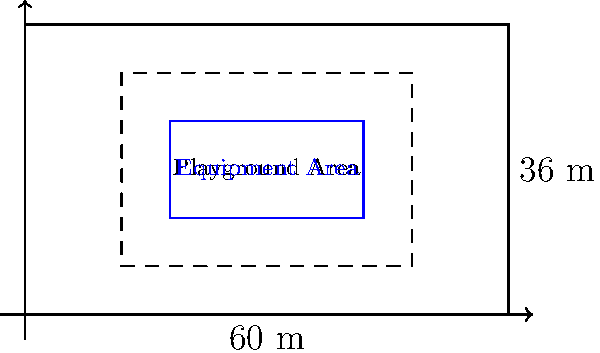As the city council member overseeing the community center, you're tasked with optimizing the layout of a new playground. The available rectangular area measures 60 meters by 36 meters. Safety regulations require a 2-meter buffer zone around all playground equipment. What is the maximum area (in square meters) that can be allocated for playground equipment while adhering to these safety requirements? Let's approach this step-by-step:

1) The total area dimensions are 60 m × 36 m.

2) We need a 2-meter buffer on all sides. This means:
   - Width reduction: 2 m on left + 2 m on right = 4 m
   - Length reduction: 2 m on top + 2 m on bottom = 4 m

3) The dimensions of the equipment area will be:
   - New width = 60 m - 4 m = 56 m
   - New length = 36 m - 4 m = 32 m

4) To calculate the maximum area for equipment:
   $$ \text{Area} = \text{width} \times \text{length} $$
   $$ \text{Area} = 56 \text{ m} \times 32 \text{ m} = 1,792 \text{ m}^2 $$

Therefore, the maximum area that can be allocated for playground equipment while maintaining the required safety buffer is 1,792 square meters.
Answer: 1,792 m² 